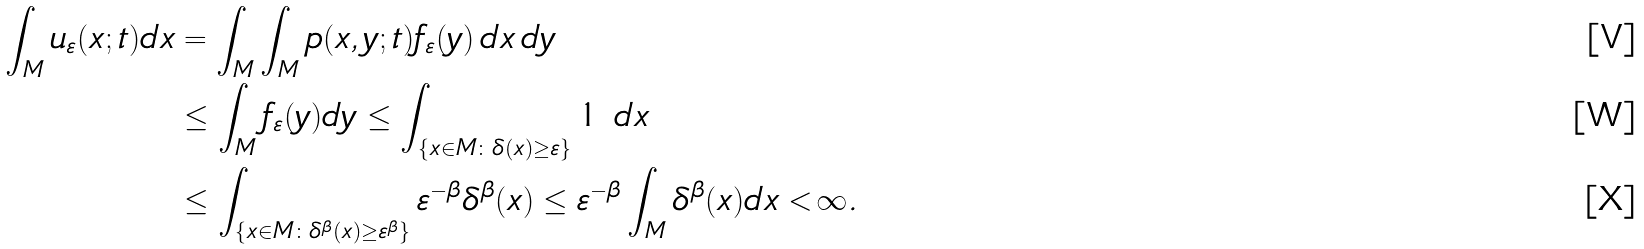Convert formula to latex. <formula><loc_0><loc_0><loc_500><loc_500>\int _ { M } u _ { \varepsilon } ( x ; t ) d x & = \int _ { M } \int _ { M } p ( x , y ; t ) f _ { \varepsilon } ( y ) \, d x \, d y \\ & \leq \int _ { M } f _ { \varepsilon } ( y ) d y \leq \int _ { \{ x \in M \colon \delta ( x ) \geq \varepsilon \} } 1 \ d x \\ & \leq \int _ { { \{ x \in M \colon \delta ^ { \beta } ( x ) \geq \varepsilon ^ { \beta } \} } } \varepsilon ^ { - \beta } \delta ^ { \beta } ( x ) \leq \varepsilon ^ { - \beta } \int _ { M } \delta ^ { \beta } ( x ) d x < \infty .</formula> 